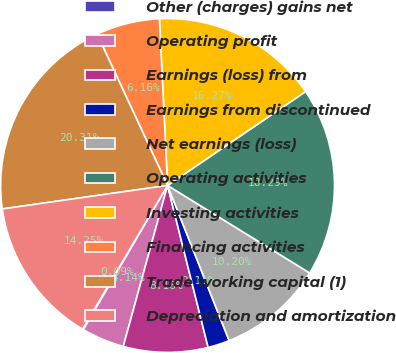Convert chart. <chart><loc_0><loc_0><loc_500><loc_500><pie_chart><fcel>Other (charges) gains net<fcel>Operating profit<fcel>Earnings (loss) from<fcel>Earnings from discontinued<fcel>Net earnings (loss)<fcel>Operating activities<fcel>Investing activities<fcel>Financing activities<fcel>Trade working capital (1)<fcel>Depreciation and amortization<nl><fcel>0.09%<fcel>4.14%<fcel>8.18%<fcel>2.11%<fcel>10.2%<fcel>18.29%<fcel>16.27%<fcel>6.16%<fcel>20.31%<fcel>14.25%<nl></chart> 